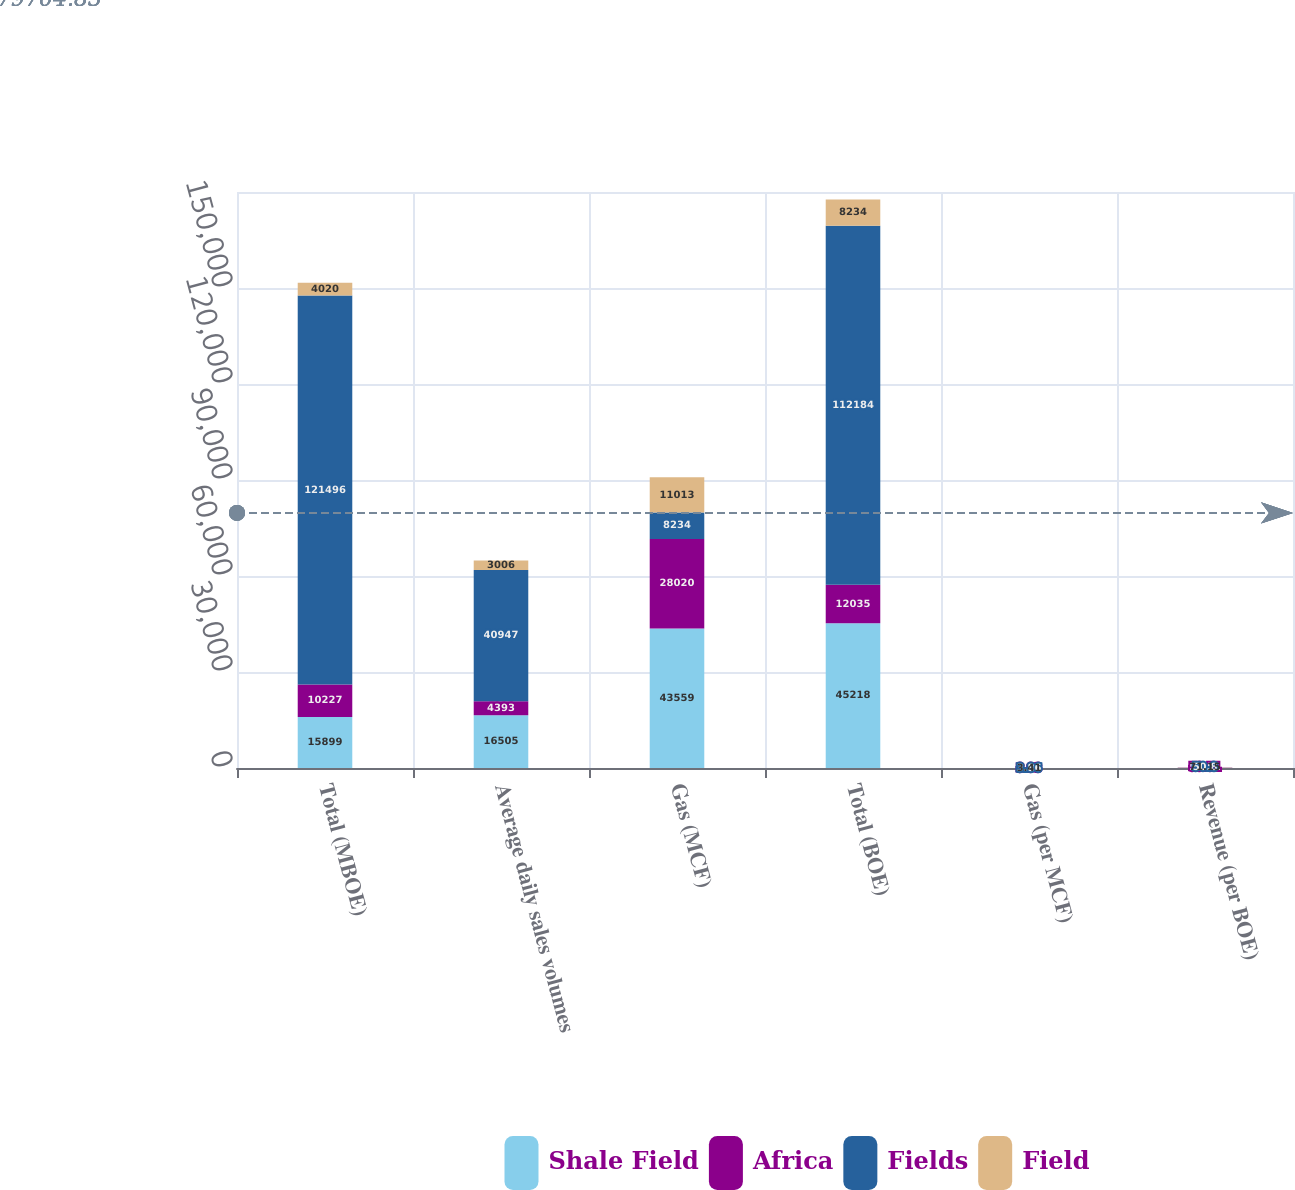Convert chart. <chart><loc_0><loc_0><loc_500><loc_500><stacked_bar_chart><ecel><fcel>Total (MBOE)<fcel>Average daily sales volumes<fcel>Gas (MCF)<fcel>Total (BOE)<fcel>Gas (per MCF)<fcel>Revenue (per BOE)<nl><fcel>Shale Field<fcel>15899<fcel>16505<fcel>43559<fcel>45218<fcel>3.44<fcel>71.37<nl><fcel>Africa<fcel>10227<fcel>4393<fcel>28020<fcel>12035<fcel>3.93<fcel>53.51<nl><fcel>Fields<fcel>121496<fcel>40947<fcel>8234<fcel>112184<fcel>3.86<fcel>50.8<nl><fcel>Field<fcel>4020<fcel>3006<fcel>11013<fcel>8234<fcel>3.41<fcel>71.15<nl></chart> 